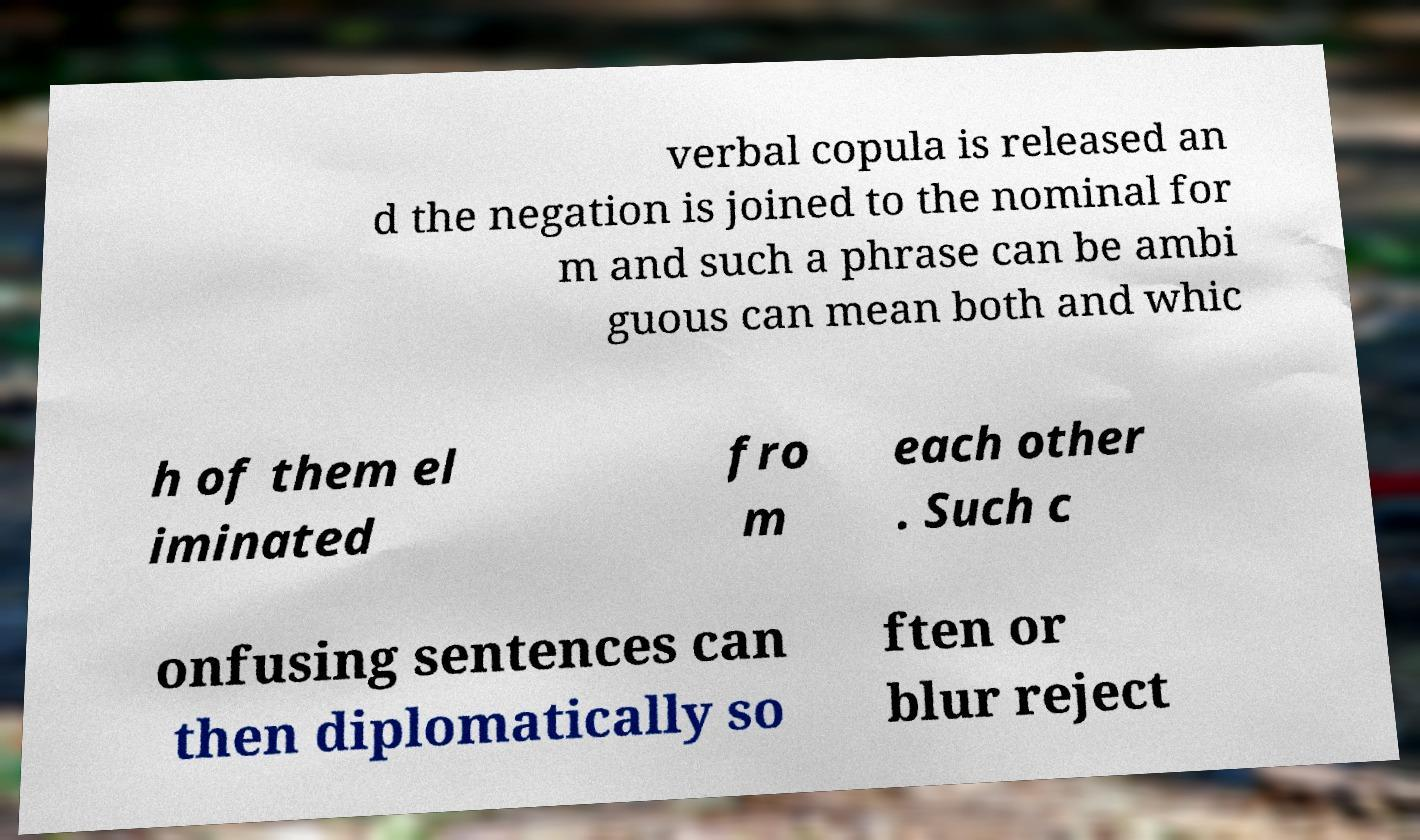Could you assist in decoding the text presented in this image and type it out clearly? verbal copula is released an d the negation is joined to the nominal for m and such a phrase can be ambi guous can mean both and whic h of them el iminated fro m each other . Such c onfusing sentences can then diplomatically so ften or blur reject 